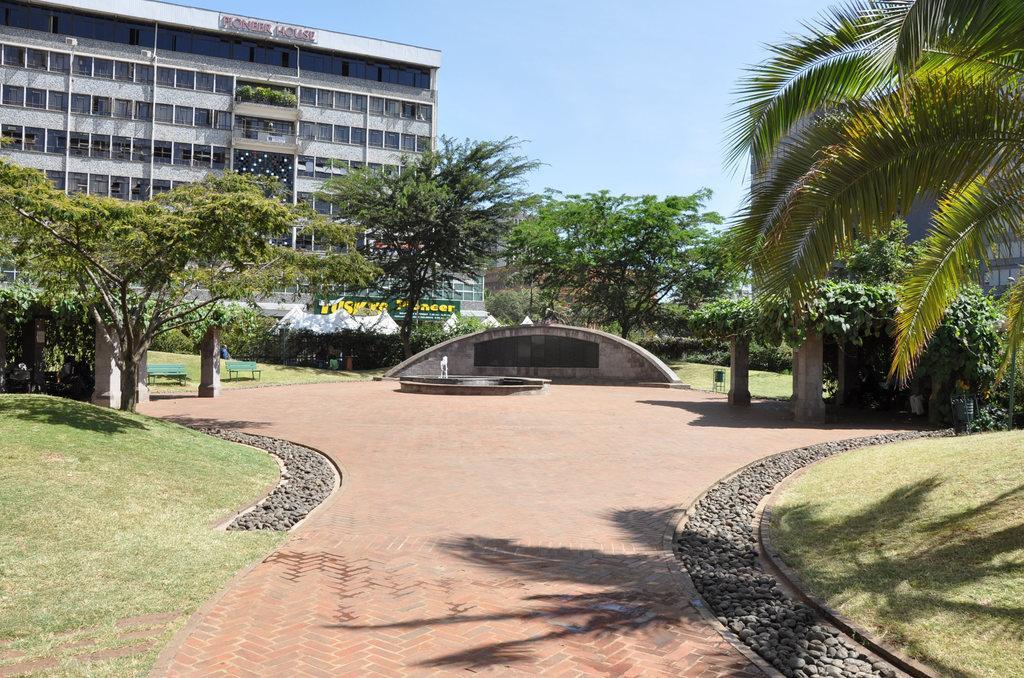Can you describe this image briefly? In this image we can see some trees and grass on the ground and there is a fountain in the middle. There are two benches and we can see the buildings in the background and at the top we can see the sky. 